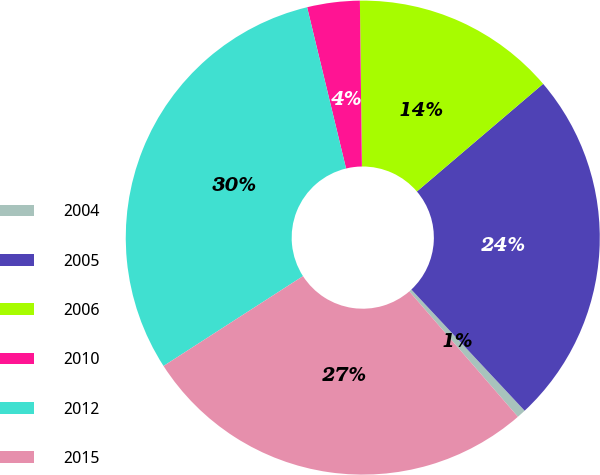<chart> <loc_0><loc_0><loc_500><loc_500><pie_chart><fcel>2004<fcel>2005<fcel>2006<fcel>2010<fcel>2012<fcel>2015<nl><fcel>0.61%<fcel>24.27%<fcel>13.96%<fcel>3.58%<fcel>30.34%<fcel>27.25%<nl></chart> 